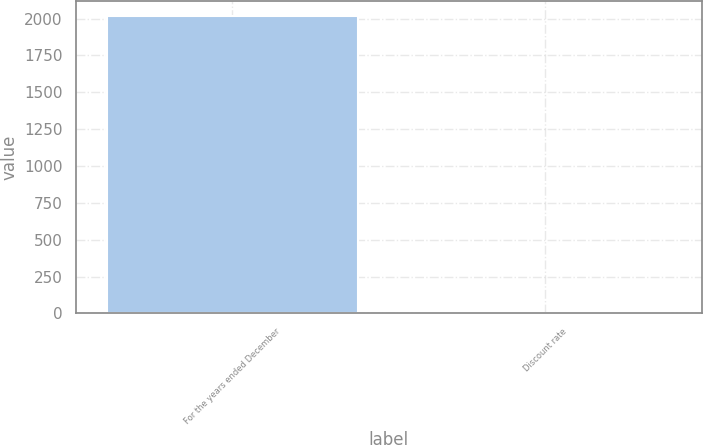<chart> <loc_0><loc_0><loc_500><loc_500><bar_chart><fcel>For the years ended December<fcel>Discount rate<nl><fcel>2018<fcel>3.4<nl></chart> 